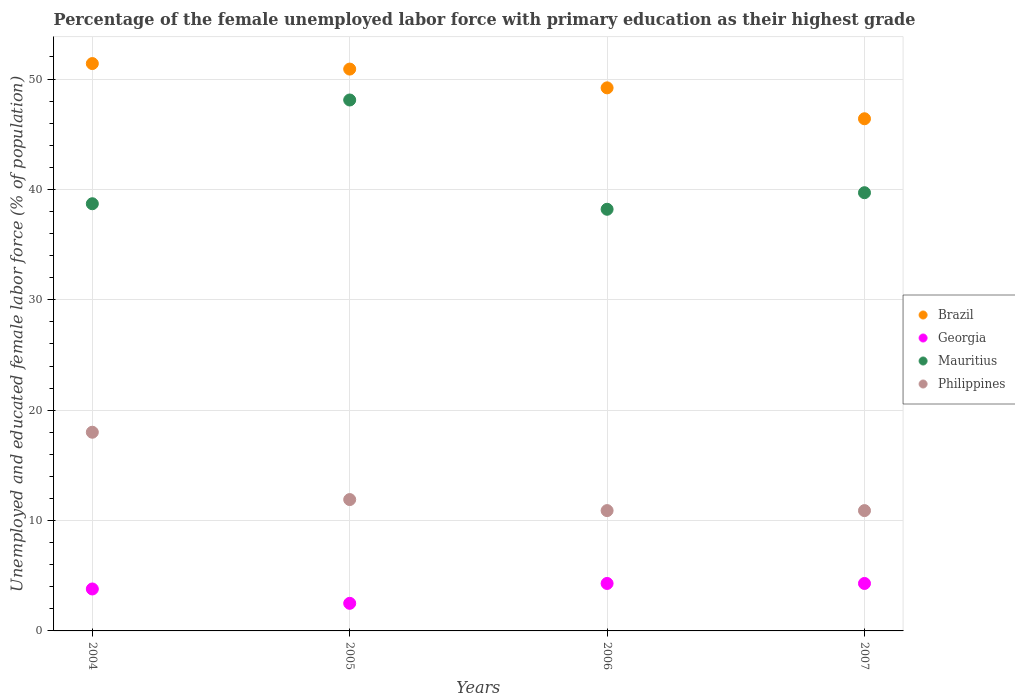What is the percentage of the unemployed female labor force with primary education in Georgia in 2006?
Your response must be concise. 4.3. Across all years, what is the maximum percentage of the unemployed female labor force with primary education in Mauritius?
Make the answer very short. 48.1. Across all years, what is the minimum percentage of the unemployed female labor force with primary education in Brazil?
Offer a terse response. 46.4. In which year was the percentage of the unemployed female labor force with primary education in Georgia maximum?
Offer a very short reply. 2006. What is the total percentage of the unemployed female labor force with primary education in Philippines in the graph?
Your answer should be compact. 51.7. What is the difference between the percentage of the unemployed female labor force with primary education in Philippines in 2004 and that in 2006?
Offer a very short reply. 7.1. What is the difference between the percentage of the unemployed female labor force with primary education in Mauritius in 2006 and the percentage of the unemployed female labor force with primary education in Georgia in 2005?
Provide a succinct answer. 35.7. What is the average percentage of the unemployed female labor force with primary education in Brazil per year?
Offer a terse response. 49.48. In the year 2007, what is the difference between the percentage of the unemployed female labor force with primary education in Brazil and percentage of the unemployed female labor force with primary education in Georgia?
Your response must be concise. 42.1. In how many years, is the percentage of the unemployed female labor force with primary education in Philippines greater than 10 %?
Keep it short and to the point. 4. What is the ratio of the percentage of the unemployed female labor force with primary education in Brazil in 2004 to that in 2005?
Your response must be concise. 1.01. What is the difference between the highest and the second highest percentage of the unemployed female labor force with primary education in Philippines?
Ensure brevity in your answer.  6.1. Is the sum of the percentage of the unemployed female labor force with primary education in Georgia in 2004 and 2006 greater than the maximum percentage of the unemployed female labor force with primary education in Brazil across all years?
Offer a very short reply. No. Is it the case that in every year, the sum of the percentage of the unemployed female labor force with primary education in Georgia and percentage of the unemployed female labor force with primary education in Mauritius  is greater than the sum of percentage of the unemployed female labor force with primary education in Philippines and percentage of the unemployed female labor force with primary education in Brazil?
Ensure brevity in your answer.  Yes. How many years are there in the graph?
Provide a short and direct response. 4. What is the difference between two consecutive major ticks on the Y-axis?
Your answer should be very brief. 10. Are the values on the major ticks of Y-axis written in scientific E-notation?
Keep it short and to the point. No. Does the graph contain any zero values?
Provide a short and direct response. No. Does the graph contain grids?
Offer a very short reply. Yes. How are the legend labels stacked?
Offer a terse response. Vertical. What is the title of the graph?
Offer a very short reply. Percentage of the female unemployed labor force with primary education as their highest grade. Does "Uruguay" appear as one of the legend labels in the graph?
Provide a short and direct response. No. What is the label or title of the X-axis?
Offer a terse response. Years. What is the label or title of the Y-axis?
Provide a succinct answer. Unemployed and educated female labor force (% of population). What is the Unemployed and educated female labor force (% of population) of Brazil in 2004?
Offer a terse response. 51.4. What is the Unemployed and educated female labor force (% of population) in Georgia in 2004?
Ensure brevity in your answer.  3.8. What is the Unemployed and educated female labor force (% of population) of Mauritius in 2004?
Your response must be concise. 38.7. What is the Unemployed and educated female labor force (% of population) of Philippines in 2004?
Make the answer very short. 18. What is the Unemployed and educated female labor force (% of population) in Brazil in 2005?
Make the answer very short. 50.9. What is the Unemployed and educated female labor force (% of population) in Mauritius in 2005?
Your response must be concise. 48.1. What is the Unemployed and educated female labor force (% of population) of Philippines in 2005?
Offer a terse response. 11.9. What is the Unemployed and educated female labor force (% of population) in Brazil in 2006?
Provide a short and direct response. 49.2. What is the Unemployed and educated female labor force (% of population) in Georgia in 2006?
Your answer should be compact. 4.3. What is the Unemployed and educated female labor force (% of population) in Mauritius in 2006?
Your answer should be compact. 38.2. What is the Unemployed and educated female labor force (% of population) in Philippines in 2006?
Your response must be concise. 10.9. What is the Unemployed and educated female labor force (% of population) in Brazil in 2007?
Your answer should be compact. 46.4. What is the Unemployed and educated female labor force (% of population) of Georgia in 2007?
Give a very brief answer. 4.3. What is the Unemployed and educated female labor force (% of population) of Mauritius in 2007?
Offer a very short reply. 39.7. What is the Unemployed and educated female labor force (% of population) of Philippines in 2007?
Make the answer very short. 10.9. Across all years, what is the maximum Unemployed and educated female labor force (% of population) of Brazil?
Your answer should be very brief. 51.4. Across all years, what is the maximum Unemployed and educated female labor force (% of population) of Georgia?
Your response must be concise. 4.3. Across all years, what is the maximum Unemployed and educated female labor force (% of population) of Mauritius?
Offer a very short reply. 48.1. Across all years, what is the minimum Unemployed and educated female labor force (% of population) of Brazil?
Your answer should be compact. 46.4. Across all years, what is the minimum Unemployed and educated female labor force (% of population) of Georgia?
Your response must be concise. 2.5. Across all years, what is the minimum Unemployed and educated female labor force (% of population) in Mauritius?
Ensure brevity in your answer.  38.2. Across all years, what is the minimum Unemployed and educated female labor force (% of population) in Philippines?
Provide a succinct answer. 10.9. What is the total Unemployed and educated female labor force (% of population) of Brazil in the graph?
Ensure brevity in your answer.  197.9. What is the total Unemployed and educated female labor force (% of population) in Mauritius in the graph?
Your response must be concise. 164.7. What is the total Unemployed and educated female labor force (% of population) in Philippines in the graph?
Offer a very short reply. 51.7. What is the difference between the Unemployed and educated female labor force (% of population) in Brazil in 2004 and that in 2005?
Offer a terse response. 0.5. What is the difference between the Unemployed and educated female labor force (% of population) of Georgia in 2004 and that in 2005?
Give a very brief answer. 1.3. What is the difference between the Unemployed and educated female labor force (% of population) of Philippines in 2004 and that in 2005?
Your response must be concise. 6.1. What is the difference between the Unemployed and educated female labor force (% of population) of Georgia in 2004 and that in 2006?
Provide a short and direct response. -0.5. What is the difference between the Unemployed and educated female labor force (% of population) of Brazil in 2004 and that in 2007?
Offer a terse response. 5. What is the difference between the Unemployed and educated female labor force (% of population) in Georgia in 2004 and that in 2007?
Provide a short and direct response. -0.5. What is the difference between the Unemployed and educated female labor force (% of population) in Philippines in 2004 and that in 2007?
Offer a very short reply. 7.1. What is the difference between the Unemployed and educated female labor force (% of population) in Georgia in 2005 and that in 2006?
Make the answer very short. -1.8. What is the difference between the Unemployed and educated female labor force (% of population) of Brazil in 2005 and that in 2007?
Keep it short and to the point. 4.5. What is the difference between the Unemployed and educated female labor force (% of population) of Georgia in 2005 and that in 2007?
Give a very brief answer. -1.8. What is the difference between the Unemployed and educated female labor force (% of population) of Mauritius in 2005 and that in 2007?
Your answer should be compact. 8.4. What is the difference between the Unemployed and educated female labor force (% of population) of Philippines in 2005 and that in 2007?
Offer a very short reply. 1. What is the difference between the Unemployed and educated female labor force (% of population) of Mauritius in 2006 and that in 2007?
Your response must be concise. -1.5. What is the difference between the Unemployed and educated female labor force (% of population) of Brazil in 2004 and the Unemployed and educated female labor force (% of population) of Georgia in 2005?
Keep it short and to the point. 48.9. What is the difference between the Unemployed and educated female labor force (% of population) in Brazil in 2004 and the Unemployed and educated female labor force (% of population) in Philippines in 2005?
Provide a short and direct response. 39.5. What is the difference between the Unemployed and educated female labor force (% of population) of Georgia in 2004 and the Unemployed and educated female labor force (% of population) of Mauritius in 2005?
Your response must be concise. -44.3. What is the difference between the Unemployed and educated female labor force (% of population) in Mauritius in 2004 and the Unemployed and educated female labor force (% of population) in Philippines in 2005?
Offer a very short reply. 26.8. What is the difference between the Unemployed and educated female labor force (% of population) of Brazil in 2004 and the Unemployed and educated female labor force (% of population) of Georgia in 2006?
Your response must be concise. 47.1. What is the difference between the Unemployed and educated female labor force (% of population) in Brazil in 2004 and the Unemployed and educated female labor force (% of population) in Philippines in 2006?
Keep it short and to the point. 40.5. What is the difference between the Unemployed and educated female labor force (% of population) in Georgia in 2004 and the Unemployed and educated female labor force (% of population) in Mauritius in 2006?
Offer a very short reply. -34.4. What is the difference between the Unemployed and educated female labor force (% of population) in Georgia in 2004 and the Unemployed and educated female labor force (% of population) in Philippines in 2006?
Provide a succinct answer. -7.1. What is the difference between the Unemployed and educated female labor force (% of population) of Mauritius in 2004 and the Unemployed and educated female labor force (% of population) of Philippines in 2006?
Provide a short and direct response. 27.8. What is the difference between the Unemployed and educated female labor force (% of population) of Brazil in 2004 and the Unemployed and educated female labor force (% of population) of Georgia in 2007?
Keep it short and to the point. 47.1. What is the difference between the Unemployed and educated female labor force (% of population) of Brazil in 2004 and the Unemployed and educated female labor force (% of population) of Mauritius in 2007?
Your answer should be compact. 11.7. What is the difference between the Unemployed and educated female labor force (% of population) of Brazil in 2004 and the Unemployed and educated female labor force (% of population) of Philippines in 2007?
Offer a very short reply. 40.5. What is the difference between the Unemployed and educated female labor force (% of population) of Georgia in 2004 and the Unemployed and educated female labor force (% of population) of Mauritius in 2007?
Ensure brevity in your answer.  -35.9. What is the difference between the Unemployed and educated female labor force (% of population) of Mauritius in 2004 and the Unemployed and educated female labor force (% of population) of Philippines in 2007?
Make the answer very short. 27.8. What is the difference between the Unemployed and educated female labor force (% of population) of Brazil in 2005 and the Unemployed and educated female labor force (% of population) of Georgia in 2006?
Ensure brevity in your answer.  46.6. What is the difference between the Unemployed and educated female labor force (% of population) in Brazil in 2005 and the Unemployed and educated female labor force (% of population) in Mauritius in 2006?
Your answer should be very brief. 12.7. What is the difference between the Unemployed and educated female labor force (% of population) in Brazil in 2005 and the Unemployed and educated female labor force (% of population) in Philippines in 2006?
Offer a terse response. 40. What is the difference between the Unemployed and educated female labor force (% of population) in Georgia in 2005 and the Unemployed and educated female labor force (% of population) in Mauritius in 2006?
Keep it short and to the point. -35.7. What is the difference between the Unemployed and educated female labor force (% of population) in Mauritius in 2005 and the Unemployed and educated female labor force (% of population) in Philippines in 2006?
Your answer should be compact. 37.2. What is the difference between the Unemployed and educated female labor force (% of population) of Brazil in 2005 and the Unemployed and educated female labor force (% of population) of Georgia in 2007?
Your response must be concise. 46.6. What is the difference between the Unemployed and educated female labor force (% of population) in Georgia in 2005 and the Unemployed and educated female labor force (% of population) in Mauritius in 2007?
Your answer should be very brief. -37.2. What is the difference between the Unemployed and educated female labor force (% of population) of Mauritius in 2005 and the Unemployed and educated female labor force (% of population) of Philippines in 2007?
Offer a terse response. 37.2. What is the difference between the Unemployed and educated female labor force (% of population) in Brazil in 2006 and the Unemployed and educated female labor force (% of population) in Georgia in 2007?
Offer a terse response. 44.9. What is the difference between the Unemployed and educated female labor force (% of population) in Brazil in 2006 and the Unemployed and educated female labor force (% of population) in Mauritius in 2007?
Provide a succinct answer. 9.5. What is the difference between the Unemployed and educated female labor force (% of population) in Brazil in 2006 and the Unemployed and educated female labor force (% of population) in Philippines in 2007?
Offer a very short reply. 38.3. What is the difference between the Unemployed and educated female labor force (% of population) in Georgia in 2006 and the Unemployed and educated female labor force (% of population) in Mauritius in 2007?
Provide a succinct answer. -35.4. What is the difference between the Unemployed and educated female labor force (% of population) of Georgia in 2006 and the Unemployed and educated female labor force (% of population) of Philippines in 2007?
Keep it short and to the point. -6.6. What is the difference between the Unemployed and educated female labor force (% of population) of Mauritius in 2006 and the Unemployed and educated female labor force (% of population) of Philippines in 2007?
Offer a very short reply. 27.3. What is the average Unemployed and educated female labor force (% of population) in Brazil per year?
Provide a short and direct response. 49.48. What is the average Unemployed and educated female labor force (% of population) in Georgia per year?
Your answer should be very brief. 3.73. What is the average Unemployed and educated female labor force (% of population) of Mauritius per year?
Provide a succinct answer. 41.17. What is the average Unemployed and educated female labor force (% of population) of Philippines per year?
Keep it short and to the point. 12.93. In the year 2004, what is the difference between the Unemployed and educated female labor force (% of population) in Brazil and Unemployed and educated female labor force (% of population) in Georgia?
Offer a very short reply. 47.6. In the year 2004, what is the difference between the Unemployed and educated female labor force (% of population) in Brazil and Unemployed and educated female labor force (% of population) in Philippines?
Provide a short and direct response. 33.4. In the year 2004, what is the difference between the Unemployed and educated female labor force (% of population) of Georgia and Unemployed and educated female labor force (% of population) of Mauritius?
Keep it short and to the point. -34.9. In the year 2004, what is the difference between the Unemployed and educated female labor force (% of population) in Mauritius and Unemployed and educated female labor force (% of population) in Philippines?
Your answer should be compact. 20.7. In the year 2005, what is the difference between the Unemployed and educated female labor force (% of population) in Brazil and Unemployed and educated female labor force (% of population) in Georgia?
Keep it short and to the point. 48.4. In the year 2005, what is the difference between the Unemployed and educated female labor force (% of population) in Brazil and Unemployed and educated female labor force (% of population) in Philippines?
Provide a succinct answer. 39. In the year 2005, what is the difference between the Unemployed and educated female labor force (% of population) of Georgia and Unemployed and educated female labor force (% of population) of Mauritius?
Keep it short and to the point. -45.6. In the year 2005, what is the difference between the Unemployed and educated female labor force (% of population) of Georgia and Unemployed and educated female labor force (% of population) of Philippines?
Your response must be concise. -9.4. In the year 2005, what is the difference between the Unemployed and educated female labor force (% of population) in Mauritius and Unemployed and educated female labor force (% of population) in Philippines?
Keep it short and to the point. 36.2. In the year 2006, what is the difference between the Unemployed and educated female labor force (% of population) of Brazil and Unemployed and educated female labor force (% of population) of Georgia?
Offer a very short reply. 44.9. In the year 2006, what is the difference between the Unemployed and educated female labor force (% of population) of Brazil and Unemployed and educated female labor force (% of population) of Philippines?
Offer a terse response. 38.3. In the year 2006, what is the difference between the Unemployed and educated female labor force (% of population) of Georgia and Unemployed and educated female labor force (% of population) of Mauritius?
Offer a terse response. -33.9. In the year 2006, what is the difference between the Unemployed and educated female labor force (% of population) in Mauritius and Unemployed and educated female labor force (% of population) in Philippines?
Your answer should be very brief. 27.3. In the year 2007, what is the difference between the Unemployed and educated female labor force (% of population) of Brazil and Unemployed and educated female labor force (% of population) of Georgia?
Provide a succinct answer. 42.1. In the year 2007, what is the difference between the Unemployed and educated female labor force (% of population) in Brazil and Unemployed and educated female labor force (% of population) in Mauritius?
Your response must be concise. 6.7. In the year 2007, what is the difference between the Unemployed and educated female labor force (% of population) of Brazil and Unemployed and educated female labor force (% of population) of Philippines?
Keep it short and to the point. 35.5. In the year 2007, what is the difference between the Unemployed and educated female labor force (% of population) in Georgia and Unemployed and educated female labor force (% of population) in Mauritius?
Offer a very short reply. -35.4. In the year 2007, what is the difference between the Unemployed and educated female labor force (% of population) of Georgia and Unemployed and educated female labor force (% of population) of Philippines?
Provide a succinct answer. -6.6. In the year 2007, what is the difference between the Unemployed and educated female labor force (% of population) of Mauritius and Unemployed and educated female labor force (% of population) of Philippines?
Your answer should be compact. 28.8. What is the ratio of the Unemployed and educated female labor force (% of population) in Brazil in 2004 to that in 2005?
Offer a terse response. 1.01. What is the ratio of the Unemployed and educated female labor force (% of population) in Georgia in 2004 to that in 2005?
Your answer should be very brief. 1.52. What is the ratio of the Unemployed and educated female labor force (% of population) of Mauritius in 2004 to that in 2005?
Provide a short and direct response. 0.8. What is the ratio of the Unemployed and educated female labor force (% of population) in Philippines in 2004 to that in 2005?
Provide a short and direct response. 1.51. What is the ratio of the Unemployed and educated female labor force (% of population) in Brazil in 2004 to that in 2006?
Your response must be concise. 1.04. What is the ratio of the Unemployed and educated female labor force (% of population) of Georgia in 2004 to that in 2006?
Give a very brief answer. 0.88. What is the ratio of the Unemployed and educated female labor force (% of population) in Mauritius in 2004 to that in 2006?
Provide a short and direct response. 1.01. What is the ratio of the Unemployed and educated female labor force (% of population) in Philippines in 2004 to that in 2006?
Ensure brevity in your answer.  1.65. What is the ratio of the Unemployed and educated female labor force (% of population) of Brazil in 2004 to that in 2007?
Provide a short and direct response. 1.11. What is the ratio of the Unemployed and educated female labor force (% of population) in Georgia in 2004 to that in 2007?
Provide a short and direct response. 0.88. What is the ratio of the Unemployed and educated female labor force (% of population) in Mauritius in 2004 to that in 2007?
Provide a short and direct response. 0.97. What is the ratio of the Unemployed and educated female labor force (% of population) of Philippines in 2004 to that in 2007?
Make the answer very short. 1.65. What is the ratio of the Unemployed and educated female labor force (% of population) in Brazil in 2005 to that in 2006?
Your answer should be compact. 1.03. What is the ratio of the Unemployed and educated female labor force (% of population) in Georgia in 2005 to that in 2006?
Provide a succinct answer. 0.58. What is the ratio of the Unemployed and educated female labor force (% of population) in Mauritius in 2005 to that in 2006?
Your response must be concise. 1.26. What is the ratio of the Unemployed and educated female labor force (% of population) of Philippines in 2005 to that in 2006?
Keep it short and to the point. 1.09. What is the ratio of the Unemployed and educated female labor force (% of population) of Brazil in 2005 to that in 2007?
Make the answer very short. 1.1. What is the ratio of the Unemployed and educated female labor force (% of population) in Georgia in 2005 to that in 2007?
Keep it short and to the point. 0.58. What is the ratio of the Unemployed and educated female labor force (% of population) in Mauritius in 2005 to that in 2007?
Your answer should be very brief. 1.21. What is the ratio of the Unemployed and educated female labor force (% of population) of Philippines in 2005 to that in 2007?
Keep it short and to the point. 1.09. What is the ratio of the Unemployed and educated female labor force (% of population) of Brazil in 2006 to that in 2007?
Your response must be concise. 1.06. What is the ratio of the Unemployed and educated female labor force (% of population) in Georgia in 2006 to that in 2007?
Offer a very short reply. 1. What is the ratio of the Unemployed and educated female labor force (% of population) of Mauritius in 2006 to that in 2007?
Make the answer very short. 0.96. What is the difference between the highest and the second highest Unemployed and educated female labor force (% of population) of Brazil?
Keep it short and to the point. 0.5. What is the difference between the highest and the second highest Unemployed and educated female labor force (% of population) of Mauritius?
Give a very brief answer. 8.4. What is the difference between the highest and the second highest Unemployed and educated female labor force (% of population) of Philippines?
Offer a terse response. 6.1. What is the difference between the highest and the lowest Unemployed and educated female labor force (% of population) in Georgia?
Offer a terse response. 1.8. What is the difference between the highest and the lowest Unemployed and educated female labor force (% of population) of Mauritius?
Provide a short and direct response. 9.9. What is the difference between the highest and the lowest Unemployed and educated female labor force (% of population) of Philippines?
Provide a succinct answer. 7.1. 